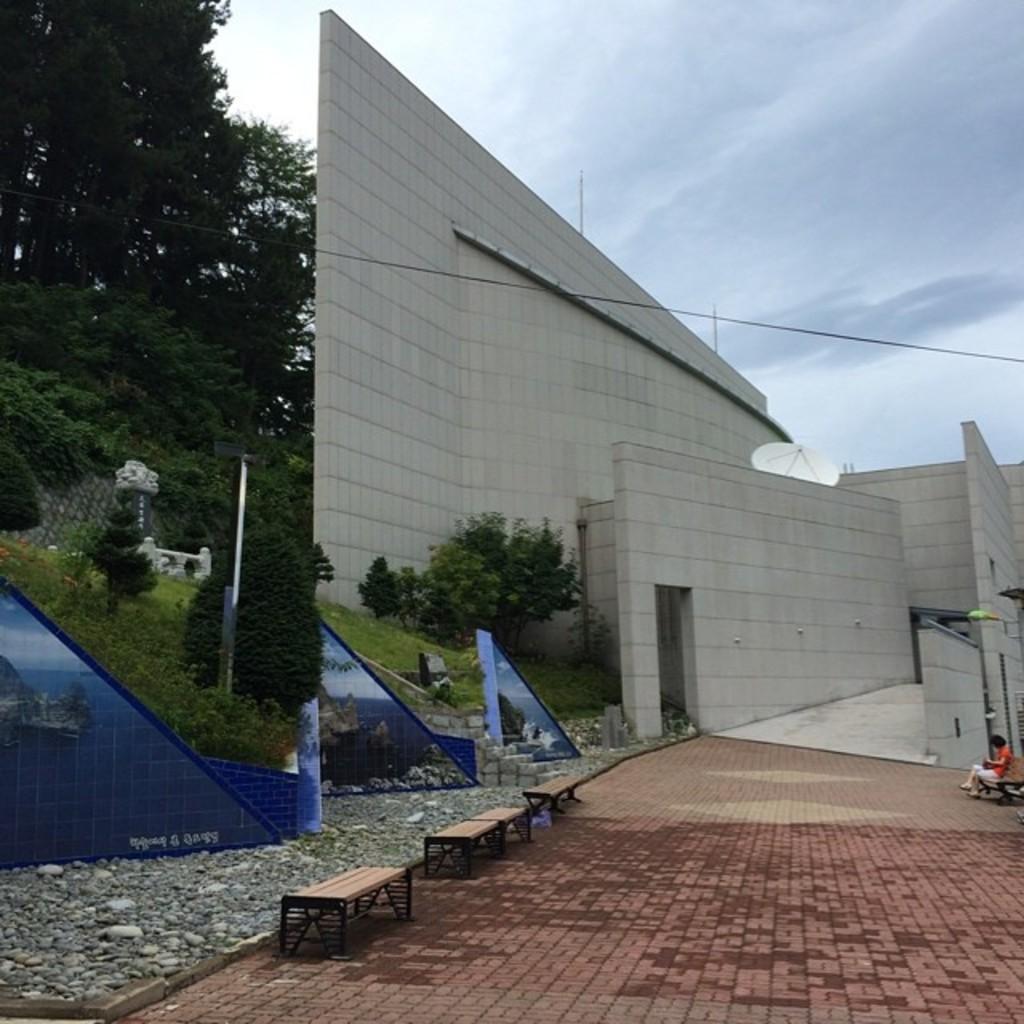Could you give a brief overview of what you see in this image? On the left side of the image we can see trees, wall and plants. In the center of the image we can see trees and building. At the bottom of the image we can see benches. In the background we can see sky and clouds. 